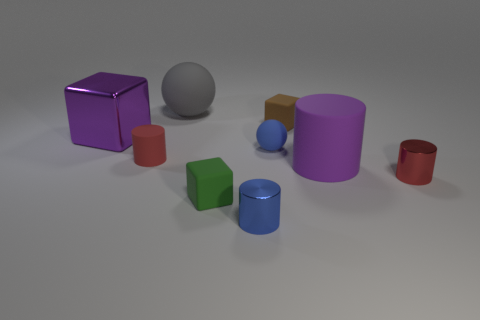How many other things are the same shape as the small green object?
Your answer should be very brief. 2. What number of metal things are big balls or large red objects?
Provide a short and direct response. 0. What material is the tiny object that is both in front of the brown matte block and right of the blue matte thing?
Your answer should be very brief. Metal. Are there any brown rubber things that are in front of the red object in front of the small red object on the left side of the tiny blue rubber thing?
Give a very brief answer. No. Is there any other thing that is the same material as the large purple cube?
Keep it short and to the point. Yes. What is the shape of the big purple thing that is the same material as the brown object?
Your answer should be very brief. Cylinder. Are there fewer big gray balls that are left of the small red rubber object than rubber cylinders that are to the right of the blue ball?
Offer a terse response. Yes. What number of large objects are either green rubber objects or matte cubes?
Make the answer very short. 0. Does the big purple thing that is to the right of the purple cube have the same shape as the small red thing that is to the left of the blue ball?
Make the answer very short. Yes. What size is the rubber ball that is in front of the purple thing that is behind the red cylinder left of the gray object?
Provide a succinct answer. Small. 